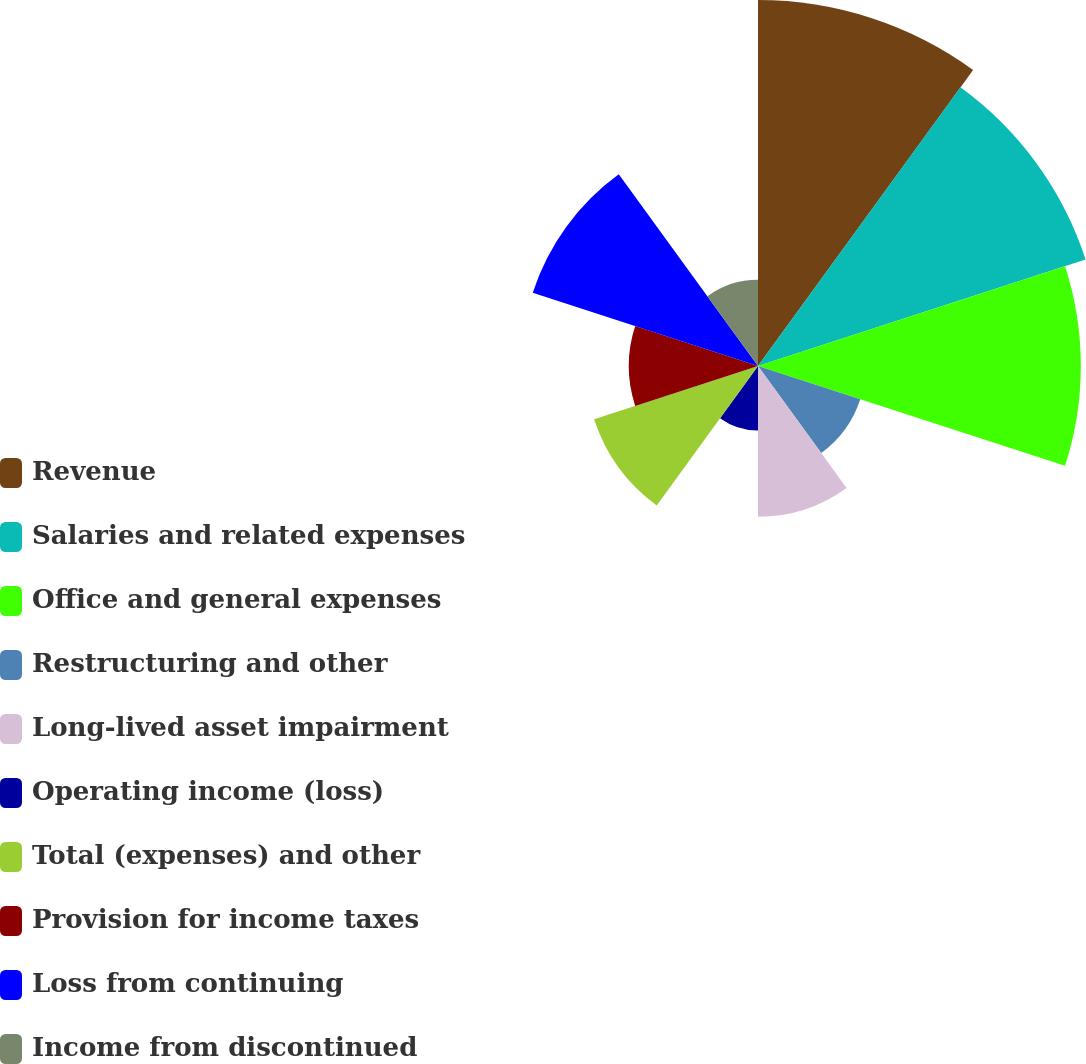Convert chart. <chart><loc_0><loc_0><loc_500><loc_500><pie_chart><fcel>Revenue<fcel>Salaries and related expenses<fcel>Office and general expenses<fcel>Restructuring and other<fcel>Long-lived asset impairment<fcel>Operating income (loss)<fcel>Total (expenses) and other<fcel>Provision for income taxes<fcel>Loss from continuing<fcel>Income from discontinued<nl><fcel>18.48%<fcel>17.39%<fcel>16.3%<fcel>5.43%<fcel>7.61%<fcel>3.26%<fcel>8.7%<fcel>6.52%<fcel>11.96%<fcel>4.35%<nl></chart> 